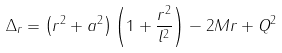<formula> <loc_0><loc_0><loc_500><loc_500>\Delta _ { r } = \left ( r ^ { 2 } + a ^ { 2 } \right ) \left ( 1 + \frac { r ^ { 2 } } { l ^ { 2 } } \right ) - 2 M r + Q ^ { 2 } \,</formula> 